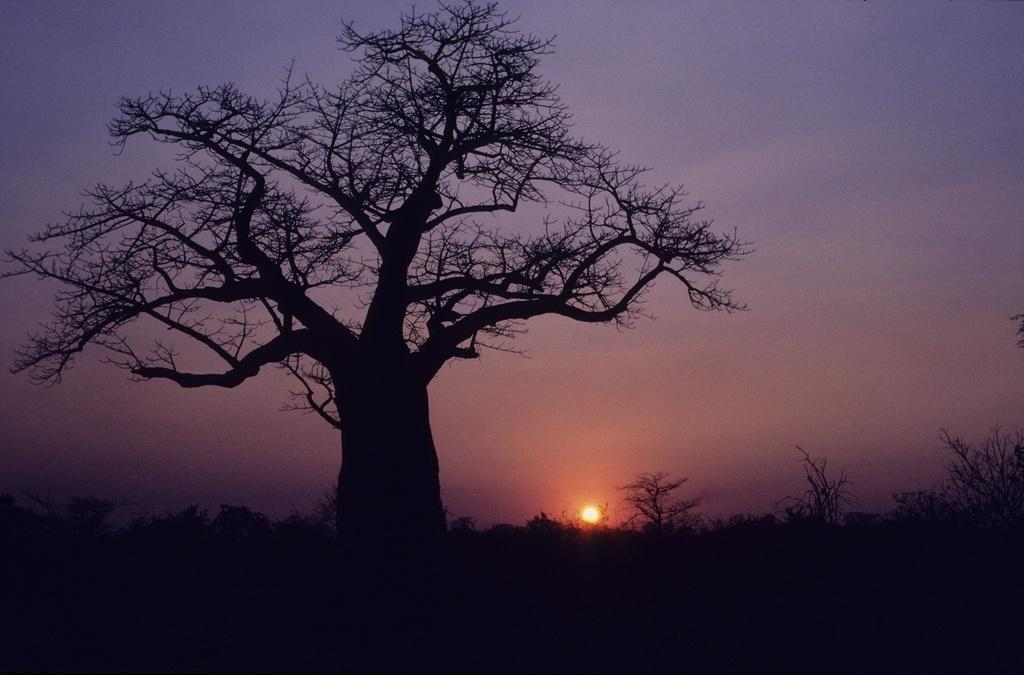What is the main subject in the center of the image? There is a tree in the center of the image. What other types of vegetation can be seen in the image? There are plants in the image. What type of ground cover is present in the image? There is grass in the image. What can be seen in the background of the image? The sky, clouds, and the sun are visible in the background of the image. What type of throat lozenge is being advertised on the tree in the image? There is no throat lozenge or advertisement present on the tree in the image. 